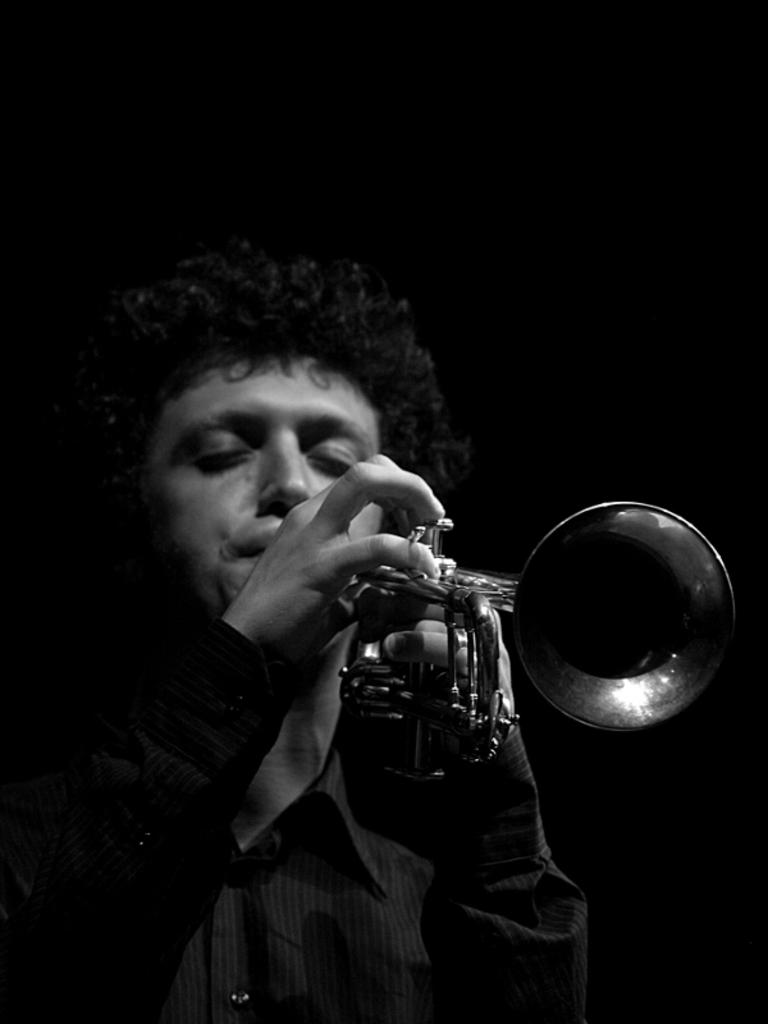Who is the main subject in the image? There is a man in the image. What is the man doing in the image? The man is playing a trumpet. What type of soap is the man using to clean the trumpet in the image? There is no soap or cleaning activity present in the image; the man is simply playing a trumpet. 